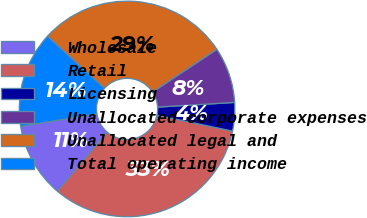Convert chart to OTSL. <chart><loc_0><loc_0><loc_500><loc_500><pie_chart><fcel>Wholesale<fcel>Retail<fcel>Licensing<fcel>Unallocated corporate expenses<fcel>Unallocated legal and<fcel>Total operating income<nl><fcel>11.23%<fcel>32.87%<fcel>4.27%<fcel>8.37%<fcel>28.88%<fcel>14.38%<nl></chart> 